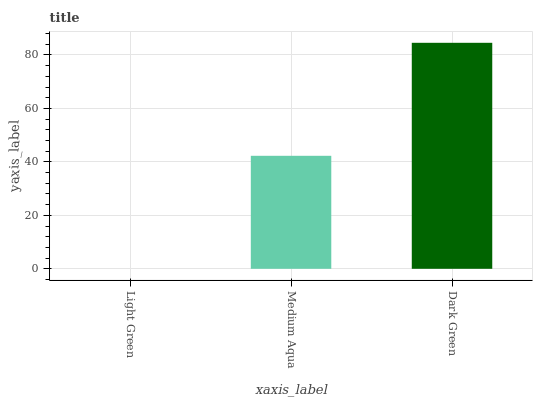Is Light Green the minimum?
Answer yes or no. Yes. Is Dark Green the maximum?
Answer yes or no. Yes. Is Medium Aqua the minimum?
Answer yes or no. No. Is Medium Aqua the maximum?
Answer yes or no. No. Is Medium Aqua greater than Light Green?
Answer yes or no. Yes. Is Light Green less than Medium Aqua?
Answer yes or no. Yes. Is Light Green greater than Medium Aqua?
Answer yes or no. No. Is Medium Aqua less than Light Green?
Answer yes or no. No. Is Medium Aqua the high median?
Answer yes or no. Yes. Is Medium Aqua the low median?
Answer yes or no. Yes. Is Dark Green the high median?
Answer yes or no. No. Is Dark Green the low median?
Answer yes or no. No. 